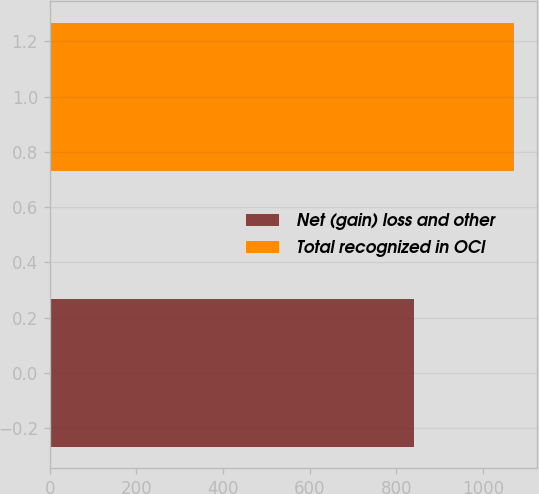Convert chart. <chart><loc_0><loc_0><loc_500><loc_500><bar_chart><fcel>Net (gain) loss and other<fcel>Total recognized in OCI<nl><fcel>840<fcel>1071<nl></chart> 